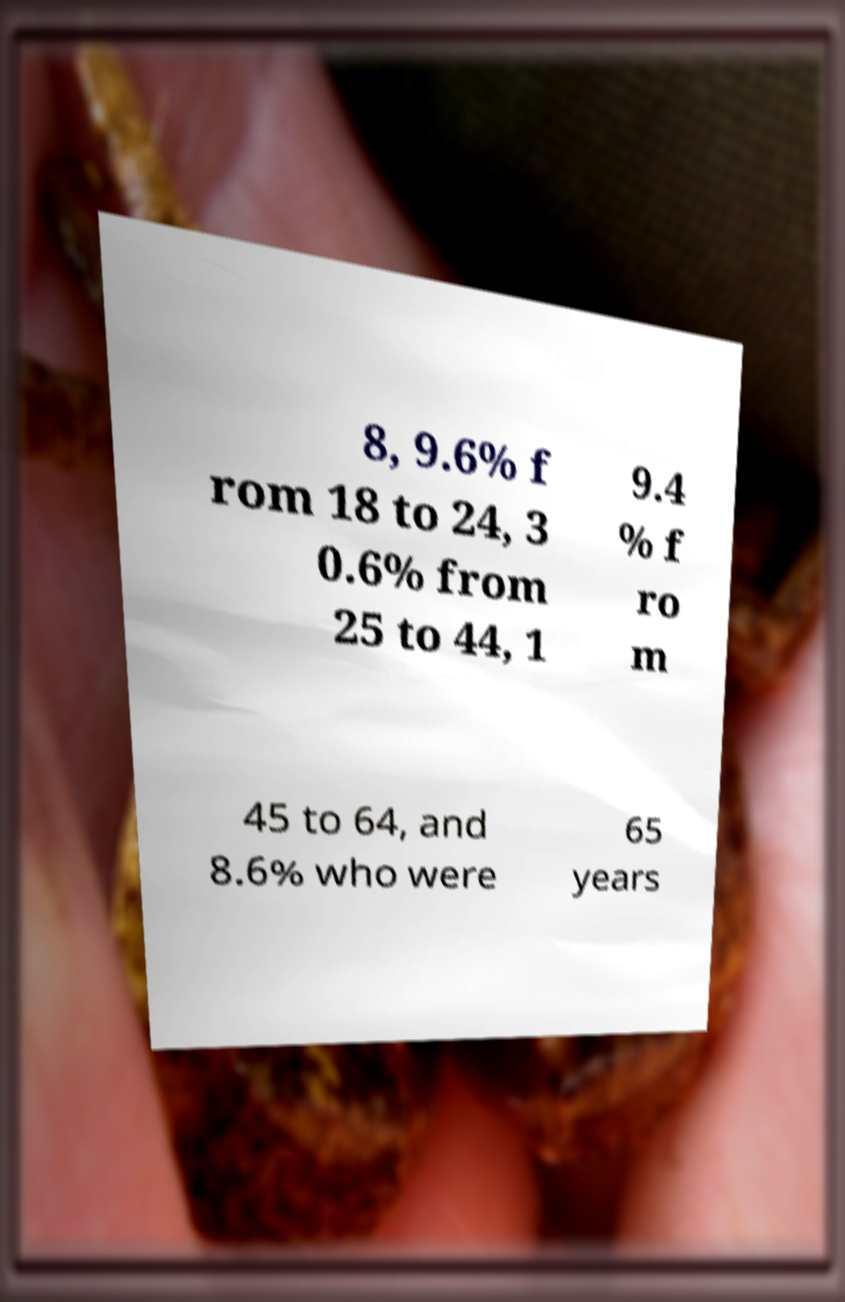For documentation purposes, I need the text within this image transcribed. Could you provide that? 8, 9.6% f rom 18 to 24, 3 0.6% from 25 to 44, 1 9.4 % f ro m 45 to 64, and 8.6% who were 65 years 